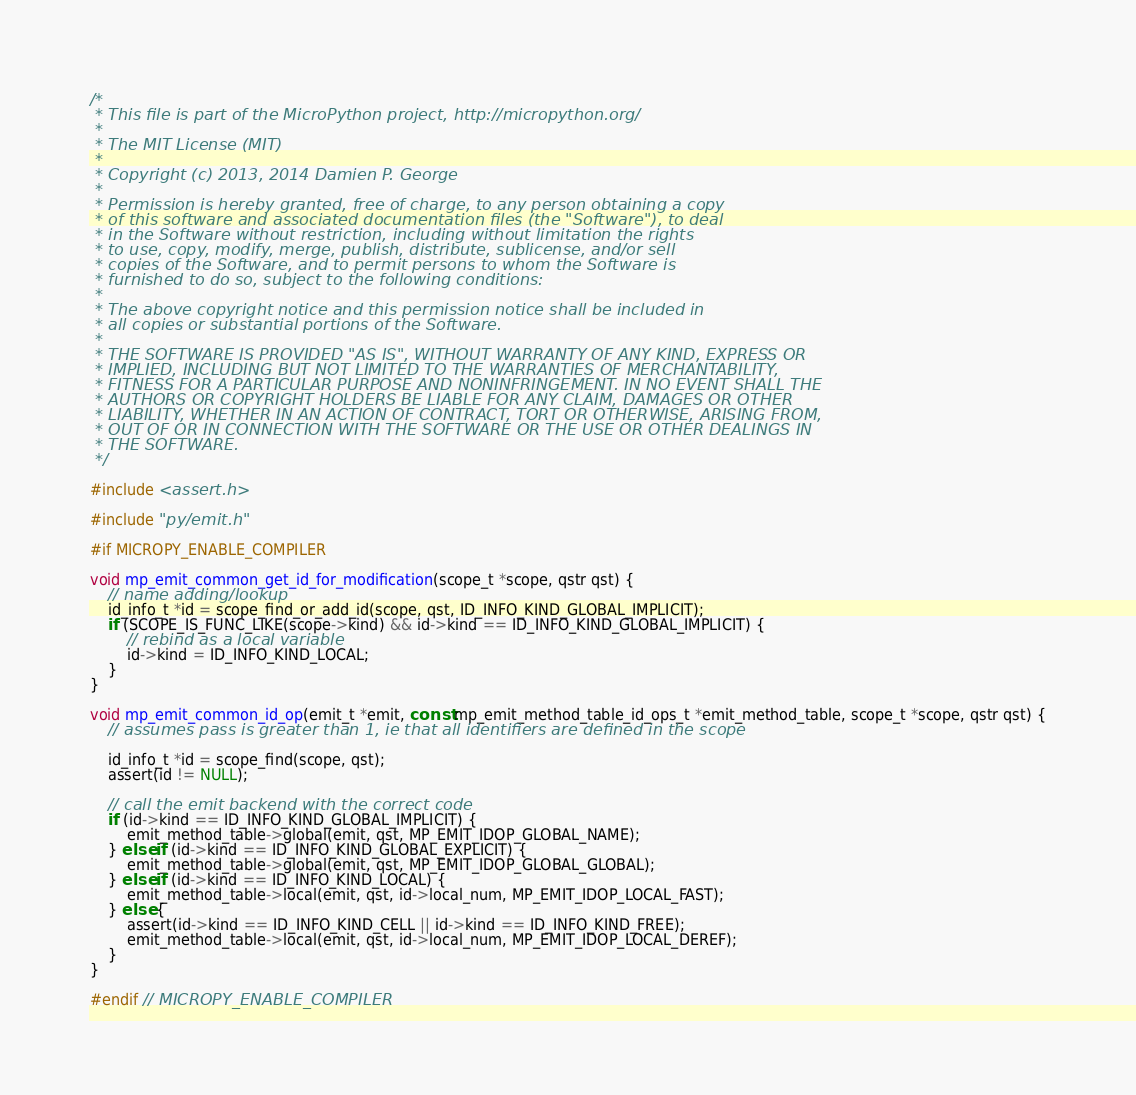Convert code to text. <code><loc_0><loc_0><loc_500><loc_500><_C_>/*
 * This file is part of the MicroPython project, http://micropython.org/
 *
 * The MIT License (MIT)
 *
 * Copyright (c) 2013, 2014 Damien P. George
 *
 * Permission is hereby granted, free of charge, to any person obtaining a copy
 * of this software and associated documentation files (the "Software"), to deal
 * in the Software without restriction, including without limitation the rights
 * to use, copy, modify, merge, publish, distribute, sublicense, and/or sell
 * copies of the Software, and to permit persons to whom the Software is
 * furnished to do so, subject to the following conditions:
 *
 * The above copyright notice and this permission notice shall be included in
 * all copies or substantial portions of the Software.
 *
 * THE SOFTWARE IS PROVIDED "AS IS", WITHOUT WARRANTY OF ANY KIND, EXPRESS OR
 * IMPLIED, INCLUDING BUT NOT LIMITED TO THE WARRANTIES OF MERCHANTABILITY,
 * FITNESS FOR A PARTICULAR PURPOSE AND NONINFRINGEMENT. IN NO EVENT SHALL THE
 * AUTHORS OR COPYRIGHT HOLDERS BE LIABLE FOR ANY CLAIM, DAMAGES OR OTHER
 * LIABILITY, WHETHER IN AN ACTION OF CONTRACT, TORT OR OTHERWISE, ARISING FROM,
 * OUT OF OR IN CONNECTION WITH THE SOFTWARE OR THE USE OR OTHER DEALINGS IN
 * THE SOFTWARE.
 */

#include <assert.h>

#include "py/emit.h"

#if MICROPY_ENABLE_COMPILER

void mp_emit_common_get_id_for_modification(scope_t *scope, qstr qst) {
    // name adding/lookup
    id_info_t *id = scope_find_or_add_id(scope, qst, ID_INFO_KIND_GLOBAL_IMPLICIT);
    if (SCOPE_IS_FUNC_LIKE(scope->kind) && id->kind == ID_INFO_KIND_GLOBAL_IMPLICIT) {
        // rebind as a local variable
        id->kind = ID_INFO_KIND_LOCAL;
    }
}

void mp_emit_common_id_op(emit_t *emit, const mp_emit_method_table_id_ops_t *emit_method_table, scope_t *scope, qstr qst) {
    // assumes pass is greater than 1, ie that all identifiers are defined in the scope

    id_info_t *id = scope_find(scope, qst);
    assert(id != NULL);

    // call the emit backend with the correct code
    if (id->kind == ID_INFO_KIND_GLOBAL_IMPLICIT) {
        emit_method_table->global(emit, qst, MP_EMIT_IDOP_GLOBAL_NAME);
    } else if (id->kind == ID_INFO_KIND_GLOBAL_EXPLICIT) {
        emit_method_table->global(emit, qst, MP_EMIT_IDOP_GLOBAL_GLOBAL);
    } else if (id->kind == ID_INFO_KIND_LOCAL) {
        emit_method_table->local(emit, qst, id->local_num, MP_EMIT_IDOP_LOCAL_FAST);
    } else {
        assert(id->kind == ID_INFO_KIND_CELL || id->kind == ID_INFO_KIND_FREE);
        emit_method_table->local(emit, qst, id->local_num, MP_EMIT_IDOP_LOCAL_DEREF);
    }
}

#endif // MICROPY_ENABLE_COMPILER
</code> 